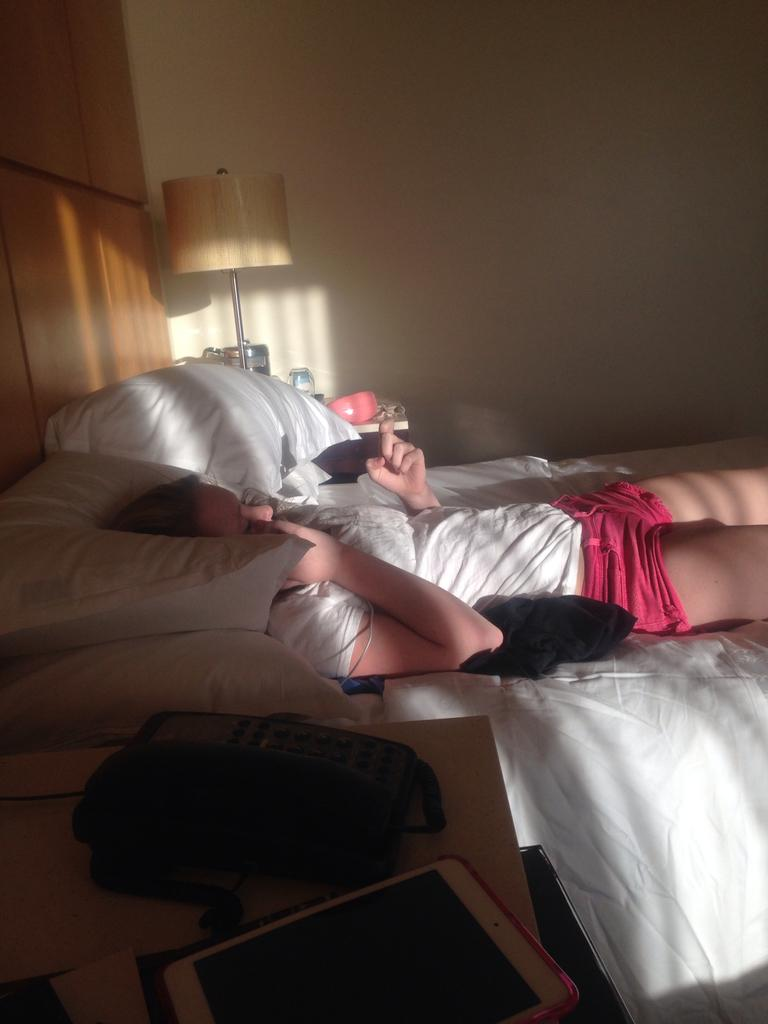What is the woman doing in the image? The woman is lying on the bed. What can be seen on the bed besides the woman? There are pillows on the bed. What objects are on the table in the image? There is a lamp, a telephone, and a tab (tablet) on the table. What type of parcel is being delivered to the woman in the image? There is no parcel being delivered to the woman in the image. What is the woman's level of fear in the image? The image does not provide any information about the woman's emotions, including fear. 